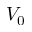<formula> <loc_0><loc_0><loc_500><loc_500>V _ { 0 }</formula> 